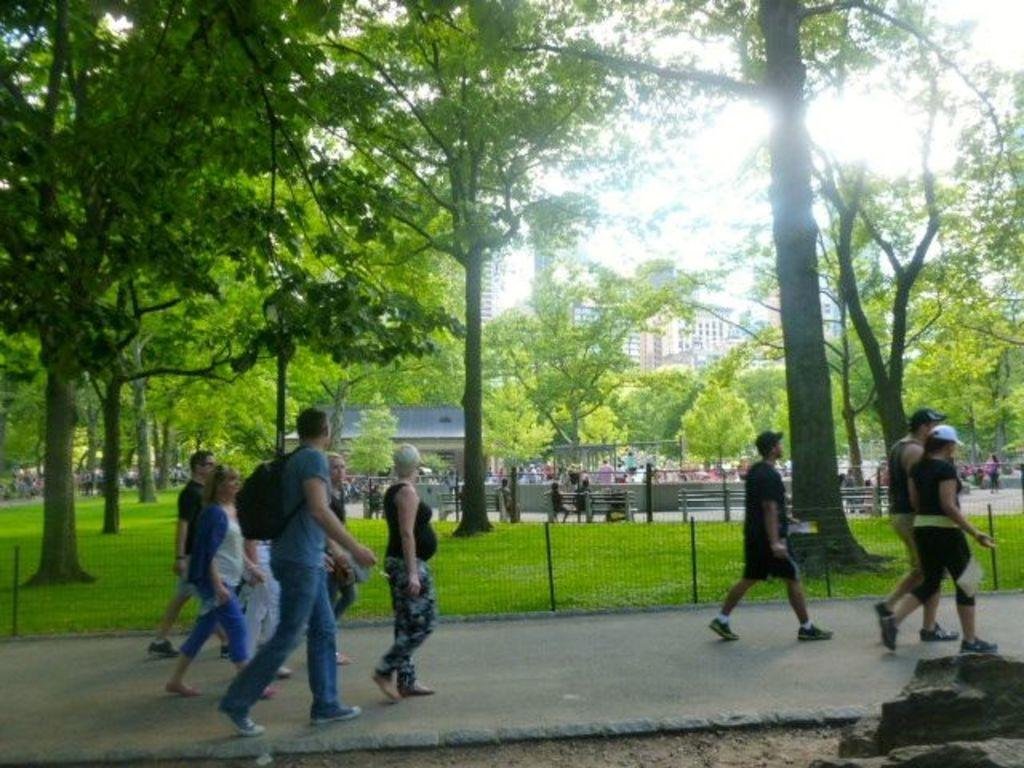What are the people in the image doing? The people in the image are walking on the road. Can you describe any accessories that some of the people are wearing? Some of the people are wearing caps. What can be seen in the background of the image? There are trees, grass, benches, buildings, and people in the background. What type of neck can be seen on the person wearing a cap in the image? There is no specific neck visible on the person wearing a cap in the image. What color are the trousers of the person sitting on the bench in the image? There is no person sitting on a bench in the image. 